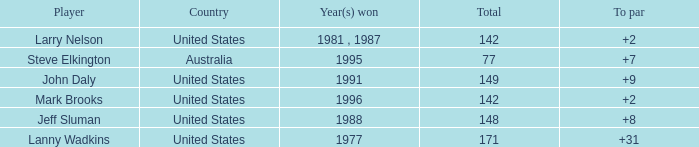Name the To par that has a Year(s) won of 1988 and a Total smaller than 148? None. 